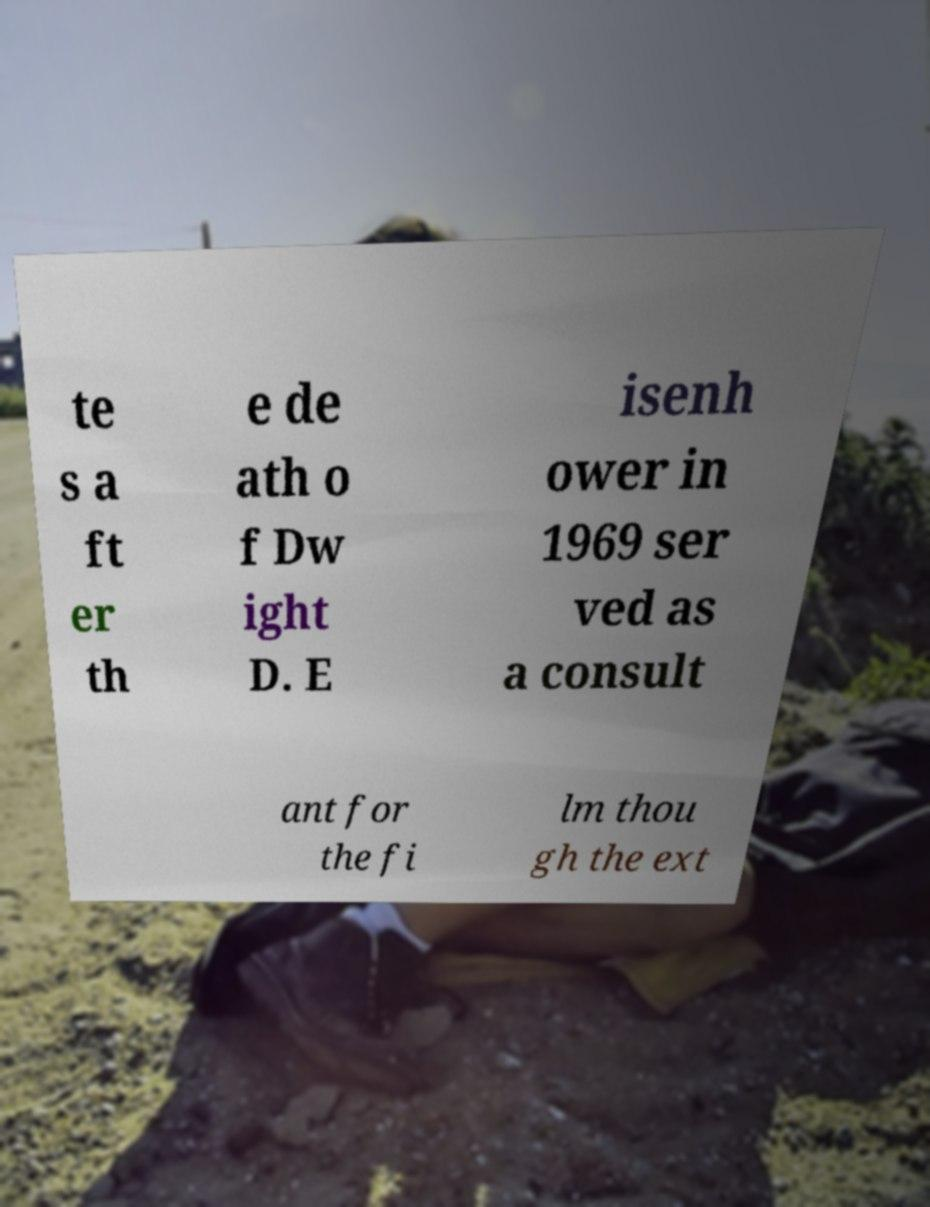I need the written content from this picture converted into text. Can you do that? te s a ft er th e de ath o f Dw ight D. E isenh ower in 1969 ser ved as a consult ant for the fi lm thou gh the ext 